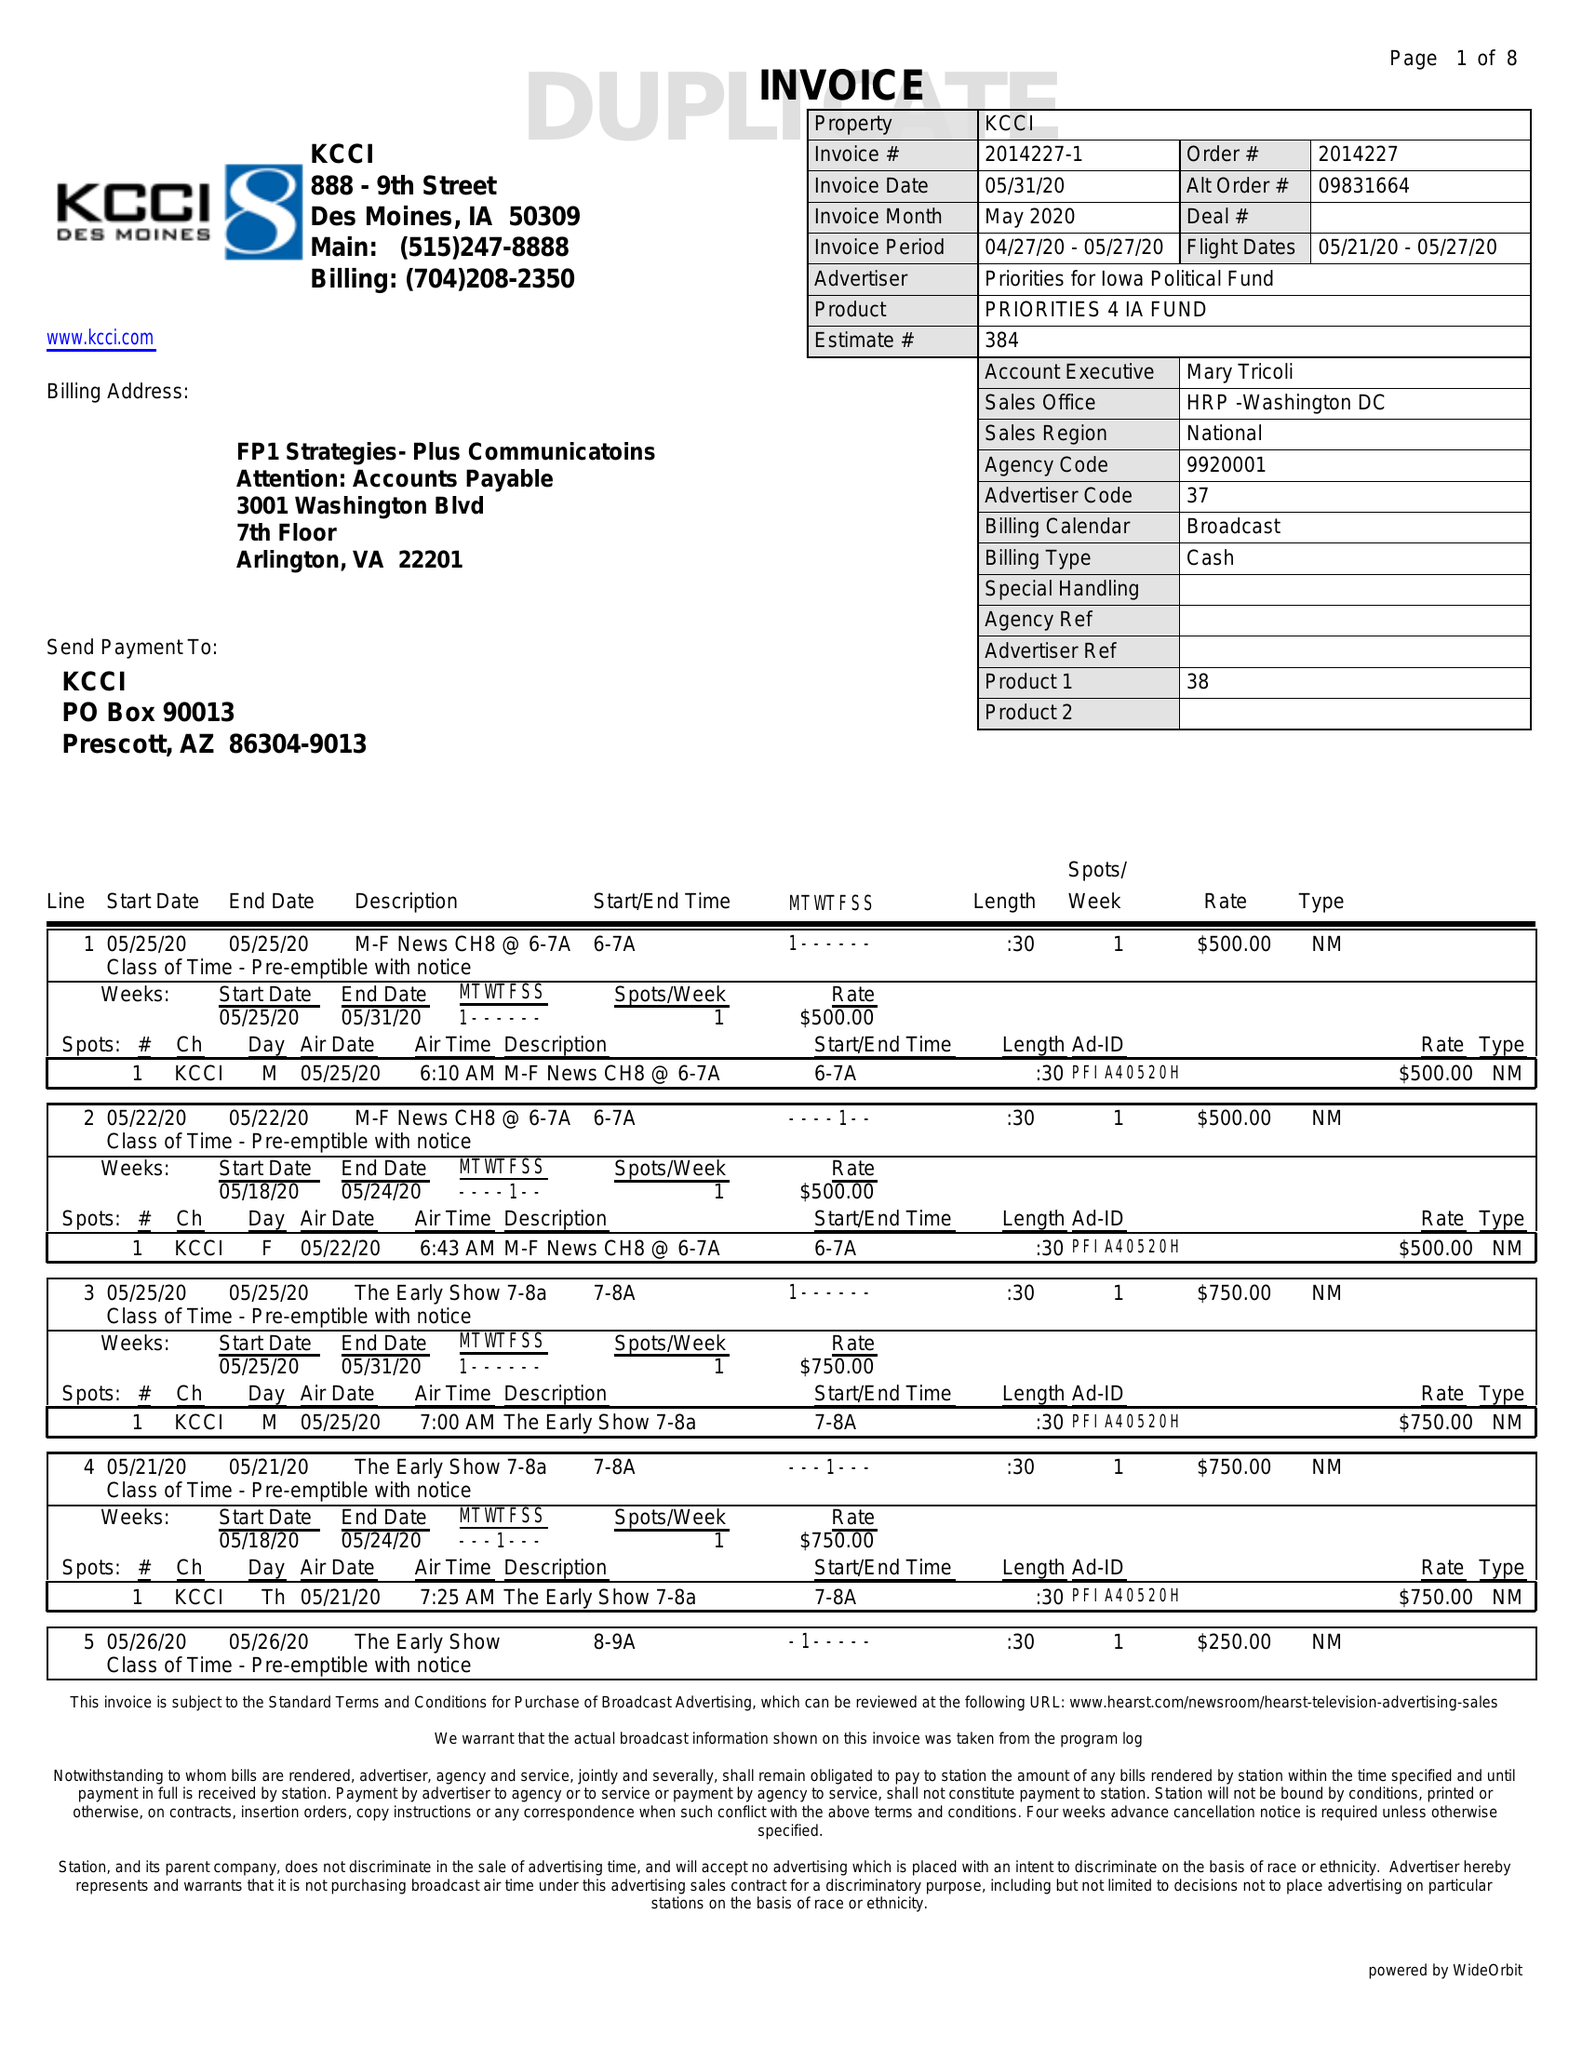What is the value for the contract_num?
Answer the question using a single word or phrase. 2014227 